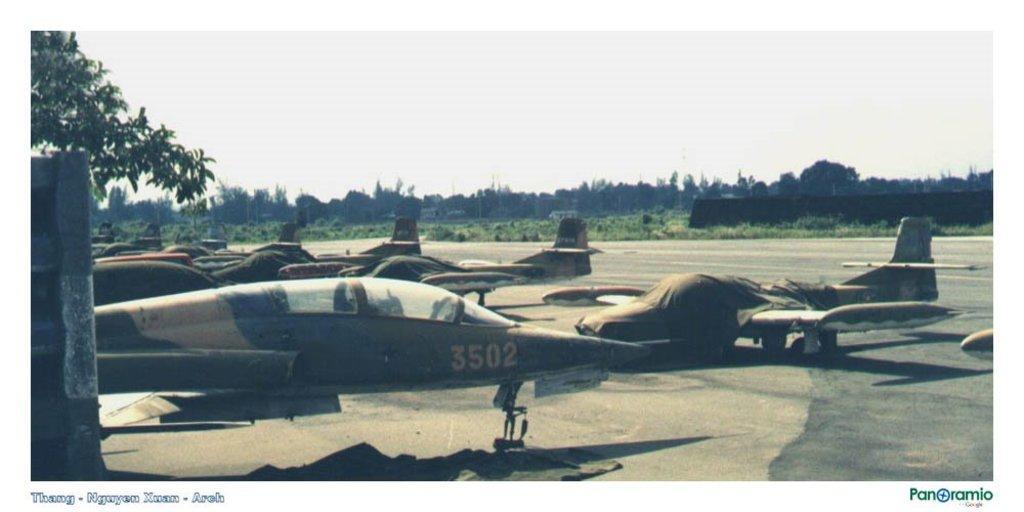Can you describe this image briefly? In this picture I can see few jet planes, trees, plants and I can see cloudy sky and text at the bottom left and bottom right corners of the picture. 